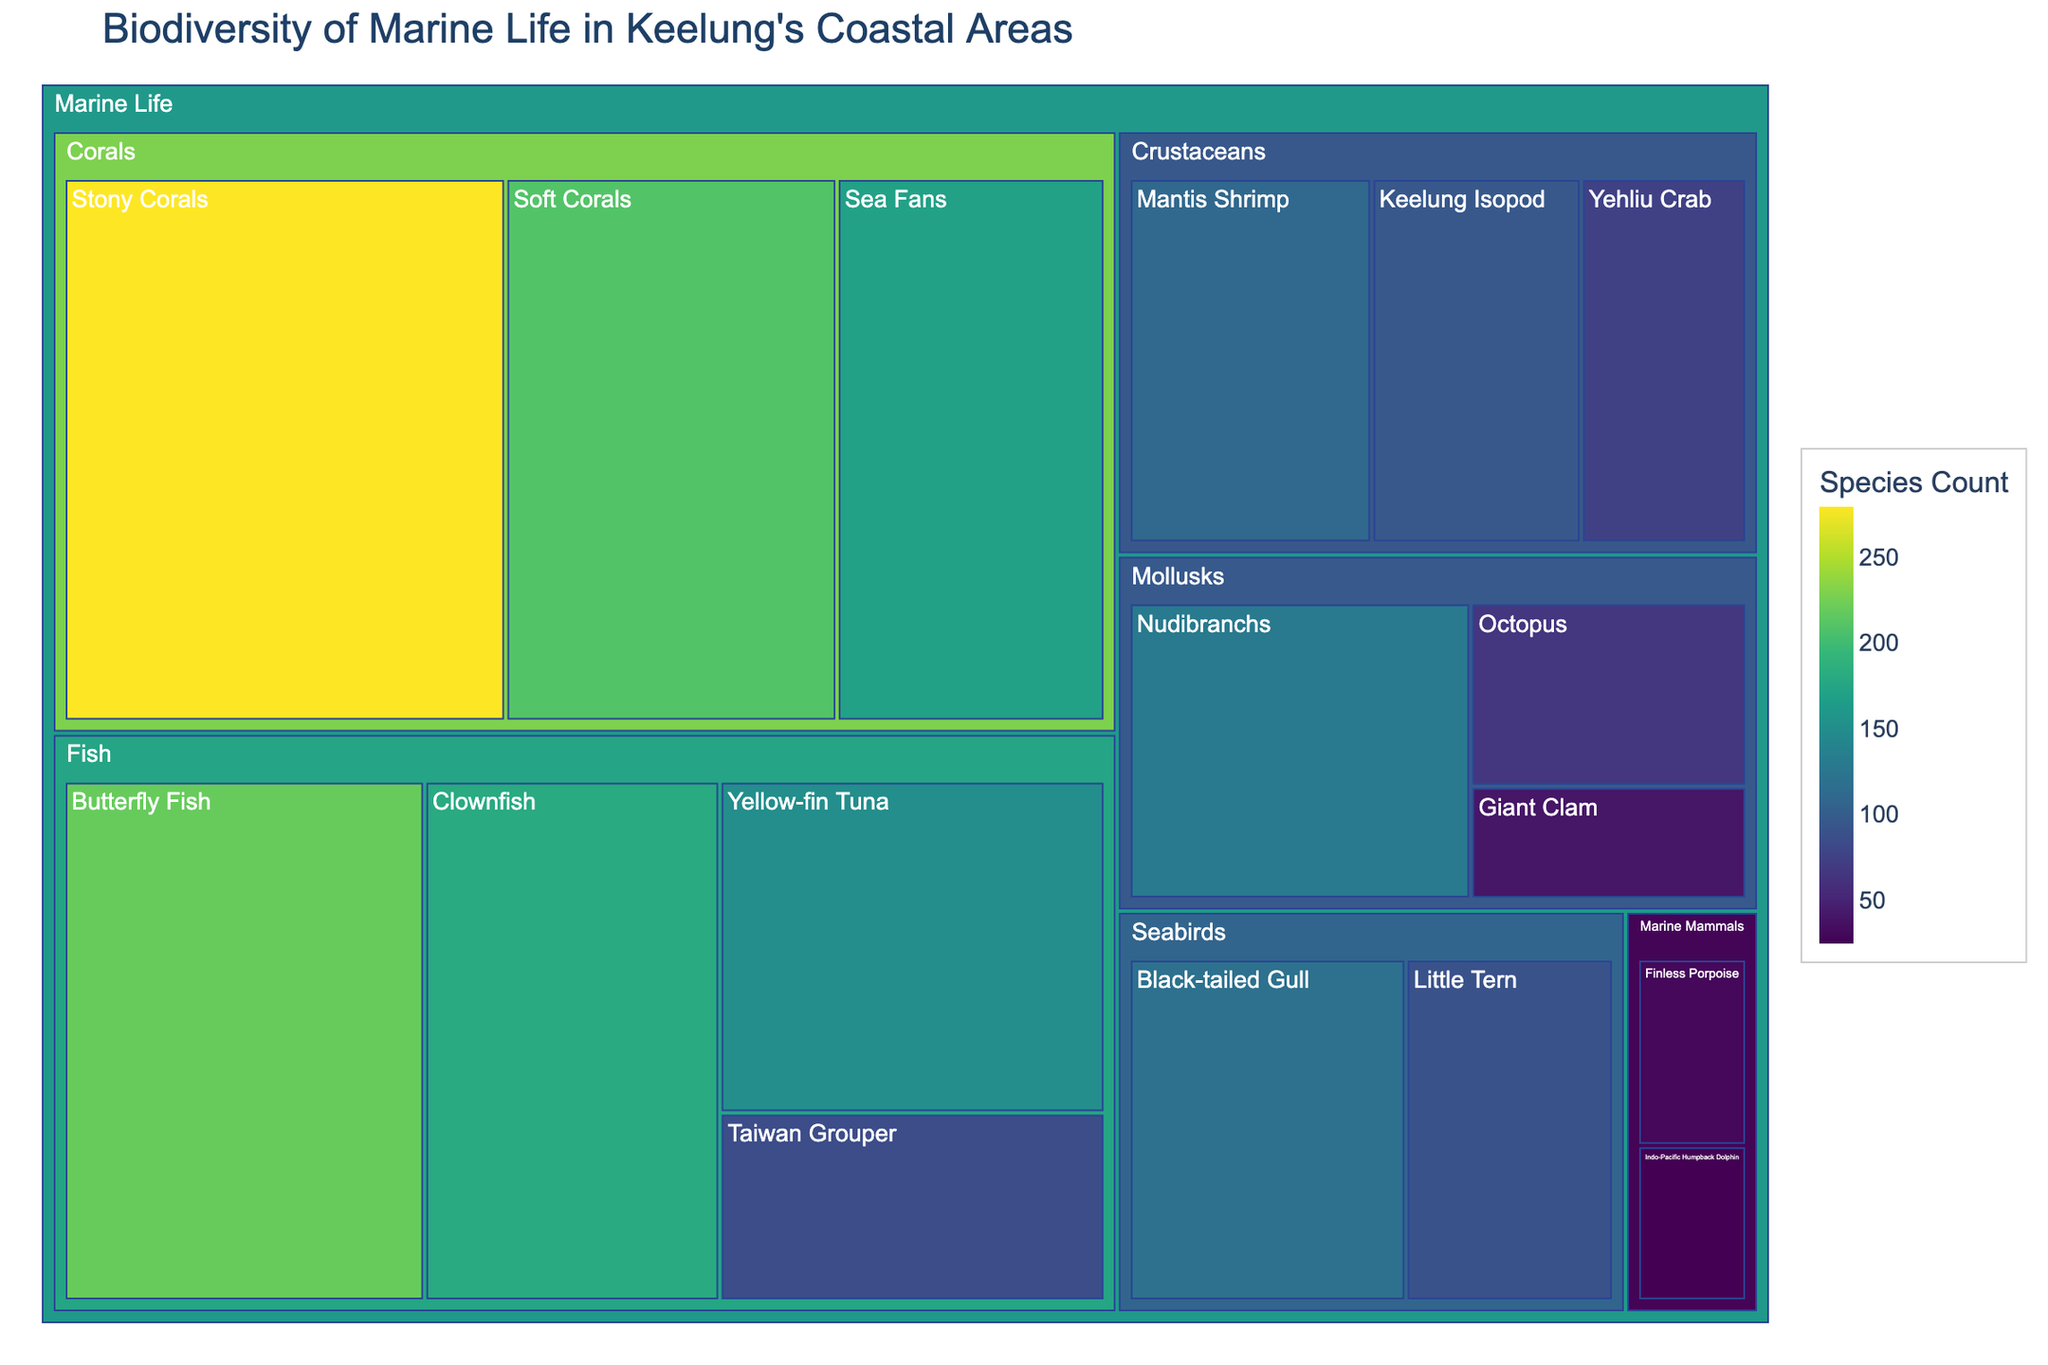What is the title of the figure? The title is usually found at the very top of the figure. It describes what the figure is about.
Answer: Biodiversity of Marine Life in Keelung's Coastal Areas Which group has the highest species count? Look at the sizes of the tiles representing each group. The largest tile corresponds to the group with the highest count.
Answer: Corals How many species of marine mammals are represented, and what is their total count? Identify the tiles under the Marine Mammals group. Sum their counts to get the total.
Answer: 2 species, total count is 55 Which species has the lowest count, and what is that count? Find the smallest tile in the treemap, which indicates the species with the lowest count.
Answer: Indo-Pacific Humpback Dolphin, 25 Compare the total counts of Fish and Seabirds. Which is greater and by how much? Calculate the total counts for Fish and Seabirds by summing their respective species counts. Compare the totals to see which is greater.
Answer: Fish is greater by 510 (635 - 125) What’s the average species count for Corals? Add the counts for all coral species and divide by the number of coral species to get the average.
Answer: 220 (660 / 3) Which species has the highest count among Mollusks and what is that count? Look at the tiles under the Mollusks group. Identify the species with the highest count.
Answer: Nudibranchs, 130 How many different groups are represented in the treemap? Count the number of unique groups under the Marine Life category in the treemap.
Answer: 6 groups Are any two species in the Fish group equal in count? Compare the counts of all species within the Fish group to check for equality.
Answer: No species are equal in count Which species group among Crustaceans has the highest count, and by how much does it exceed the other species in its group? Identify the species with the highest count in the Crustaceans group and subtract the counts of other species in the same group.
Answer: Mantis Shrimp exceeds by 110 - 95 = 15 